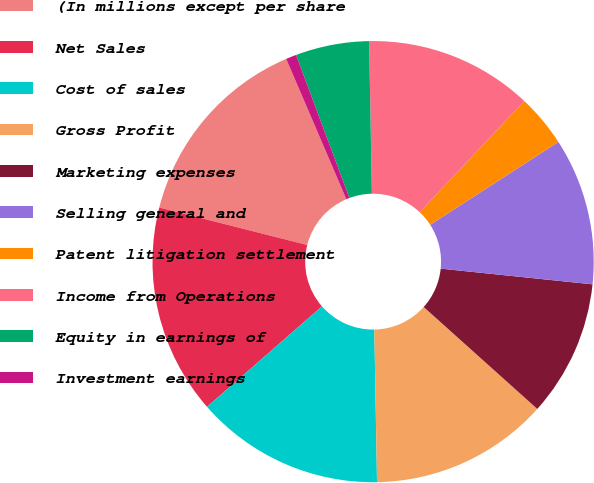Convert chart to OTSL. <chart><loc_0><loc_0><loc_500><loc_500><pie_chart><fcel>(In millions except per share<fcel>Net Sales<fcel>Cost of sales<fcel>Gross Profit<fcel>Marketing expenses<fcel>Selling general and<fcel>Patent litigation settlement<fcel>Income from Operations<fcel>Equity in earnings of<fcel>Investment earnings<nl><fcel>14.61%<fcel>15.38%<fcel>13.85%<fcel>13.08%<fcel>10.0%<fcel>10.77%<fcel>3.85%<fcel>12.31%<fcel>5.39%<fcel>0.77%<nl></chart> 